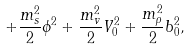<formula> <loc_0><loc_0><loc_500><loc_500>+ \frac { m _ { s } ^ { 2 } } { 2 } \phi ^ { 2 } + \frac { m _ { v } ^ { 2 } } { 2 } V _ { 0 } ^ { 2 } + \frac { m _ { \rho } ^ { 2 } } { 2 } b _ { 0 } ^ { 2 } ,</formula> 